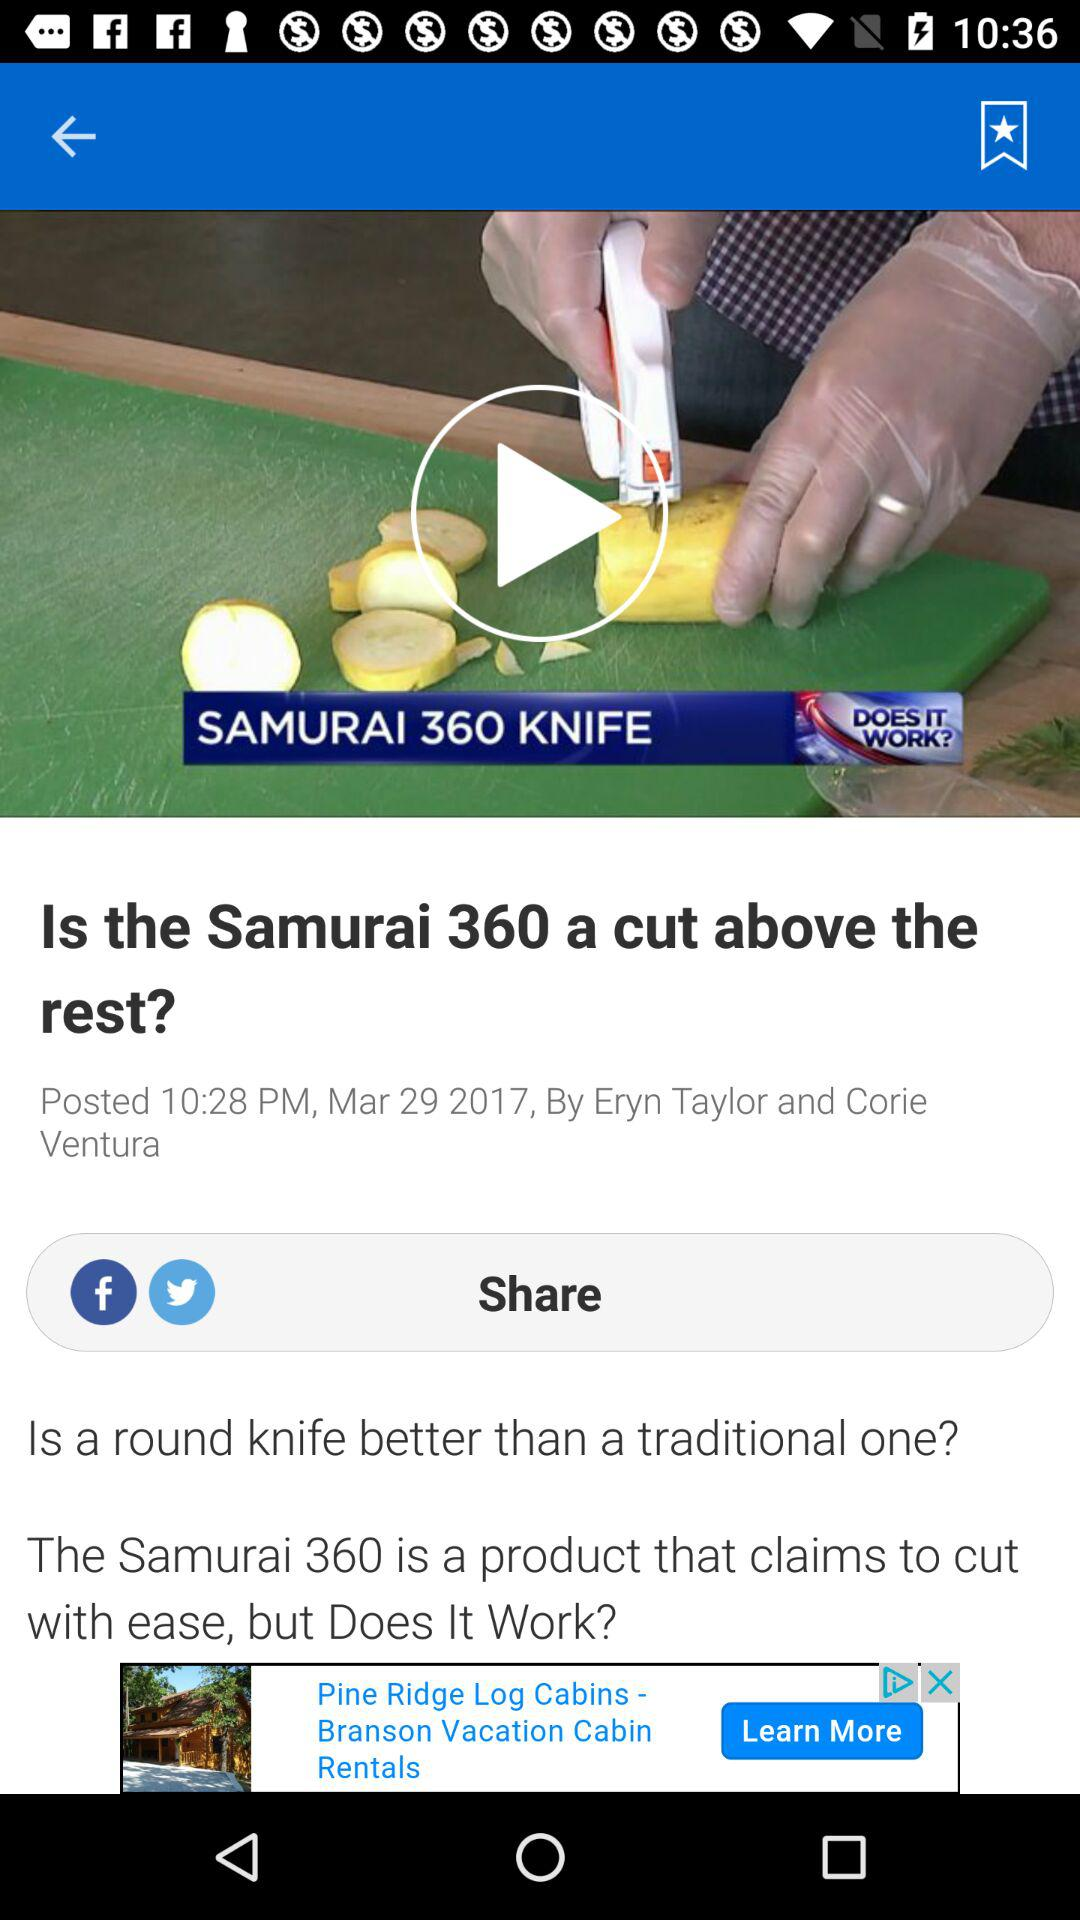What is the headline of the article? The headline of the article is "Is the Samurai 360 a cut above the rest?". 